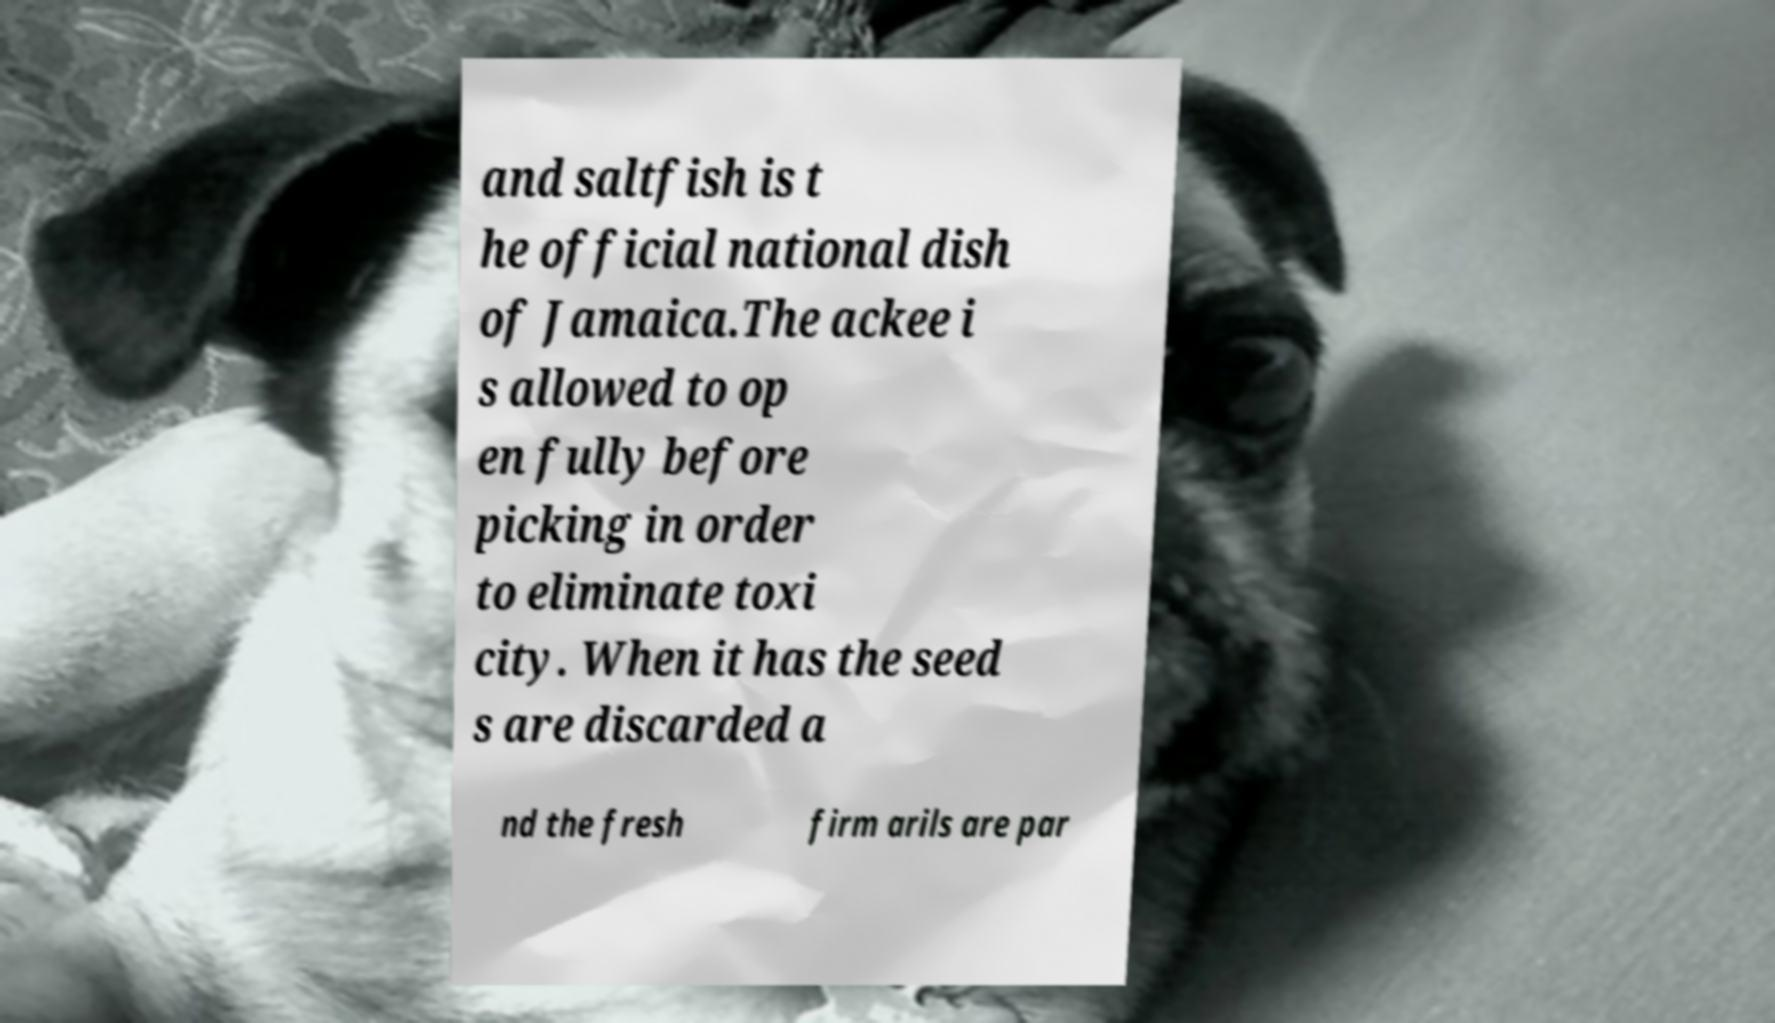For documentation purposes, I need the text within this image transcribed. Could you provide that? and saltfish is t he official national dish of Jamaica.The ackee i s allowed to op en fully before picking in order to eliminate toxi city. When it has the seed s are discarded a nd the fresh firm arils are par 